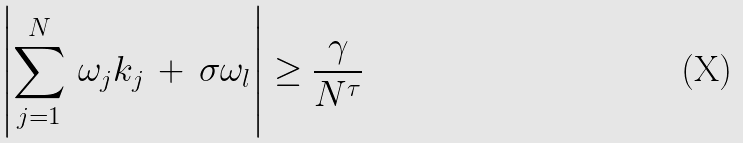Convert formula to latex. <formula><loc_0><loc_0><loc_500><loc_500>\left | \sum _ { j = 1 } ^ { N } \, \omega _ { j } k _ { j } \, + \, \sigma \omega _ { l } \right | & \geq \frac { \gamma } { N ^ { \tau } }</formula> 